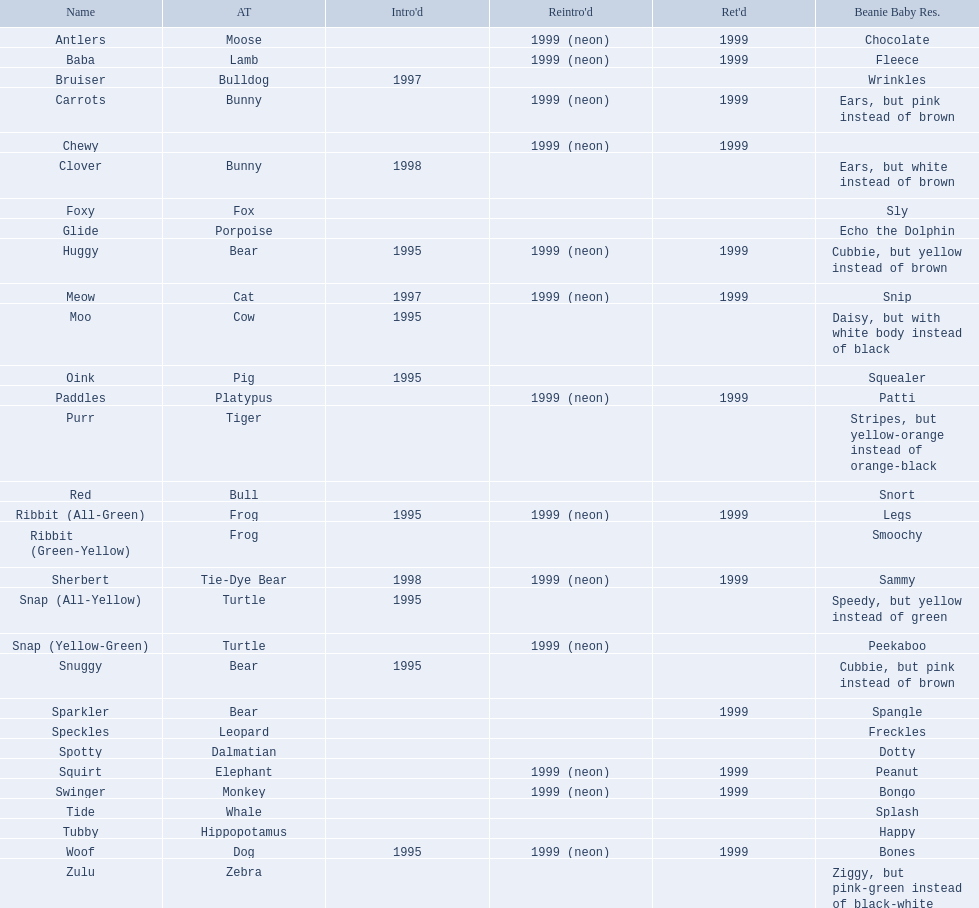What are the types of pillow pal animals? Antlers, Moose, Lamb, Bulldog, Bunny, , Bunny, Fox, Porpoise, Bear, Cat, Cow, Pig, Platypus, Tiger, Bull, Frog, Frog, Tie-Dye Bear, Turtle, Turtle, Bear, Bear, Leopard, Dalmatian, Elephant, Monkey, Whale, Hippopotamus, Dog, Zebra. Of those, which is a dalmatian? Dalmatian. What is the name of the dalmatian? Spotty. 